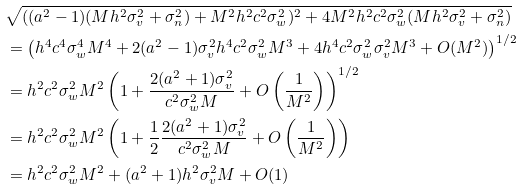<formula> <loc_0><loc_0><loc_500><loc_500>& \sqrt { ( ( a ^ { 2 } - 1 ) ( M h ^ { 2 } \sigma _ { v } ^ { 2 } + \sigma _ { n } ^ { 2 } ) + M ^ { 2 } h ^ { 2 } c ^ { 2 } \sigma _ { w } ^ { 2 } ) ^ { 2 } + 4 M ^ { 2 } h ^ { 2 } c ^ { 2 } \sigma _ { w } ^ { 2 } ( M h ^ { 2 } \sigma _ { v } ^ { 2 } + \sigma _ { n } ^ { 2 } ) } \\ & = \left ( h ^ { 4 } c ^ { 4 } \sigma _ { w } ^ { 4 } M ^ { 4 } + 2 ( a ^ { 2 } - 1 ) \sigma _ { v } ^ { 2 } h ^ { 4 } c ^ { 2 } \sigma _ { w } ^ { 2 } M ^ { 3 } + 4 h ^ { 4 } c ^ { 2 } \sigma _ { w } ^ { 2 } \sigma _ { v } ^ { 2 } M ^ { 3 } + O ( M ^ { 2 } ) \right ) ^ { 1 / 2 } \\ & = h ^ { 2 } c ^ { 2 } \sigma _ { w } ^ { 2 } M ^ { 2 } \left ( 1 + \frac { 2 ( a ^ { 2 } + 1 ) \sigma _ { v } ^ { 2 } } { c ^ { 2 } \sigma _ { w } ^ { 2 } M } + O \left ( \frac { 1 } { M ^ { 2 } } \right ) \right ) ^ { 1 / 2 } \\ & = h ^ { 2 } c ^ { 2 } \sigma _ { w } ^ { 2 } M ^ { 2 } \left ( 1 + \frac { 1 } { 2 } \frac { 2 ( a ^ { 2 } + 1 ) \sigma _ { v } ^ { 2 } } { c ^ { 2 } \sigma _ { w } ^ { 2 } M } + O \left ( \frac { 1 } { M ^ { 2 } } \right ) \right ) \\ & = h ^ { 2 } c ^ { 2 } \sigma _ { w } ^ { 2 } M ^ { 2 } + ( a ^ { 2 } + 1 ) h ^ { 2 } \sigma _ { v } ^ { 2 } M + O ( 1 )</formula> 